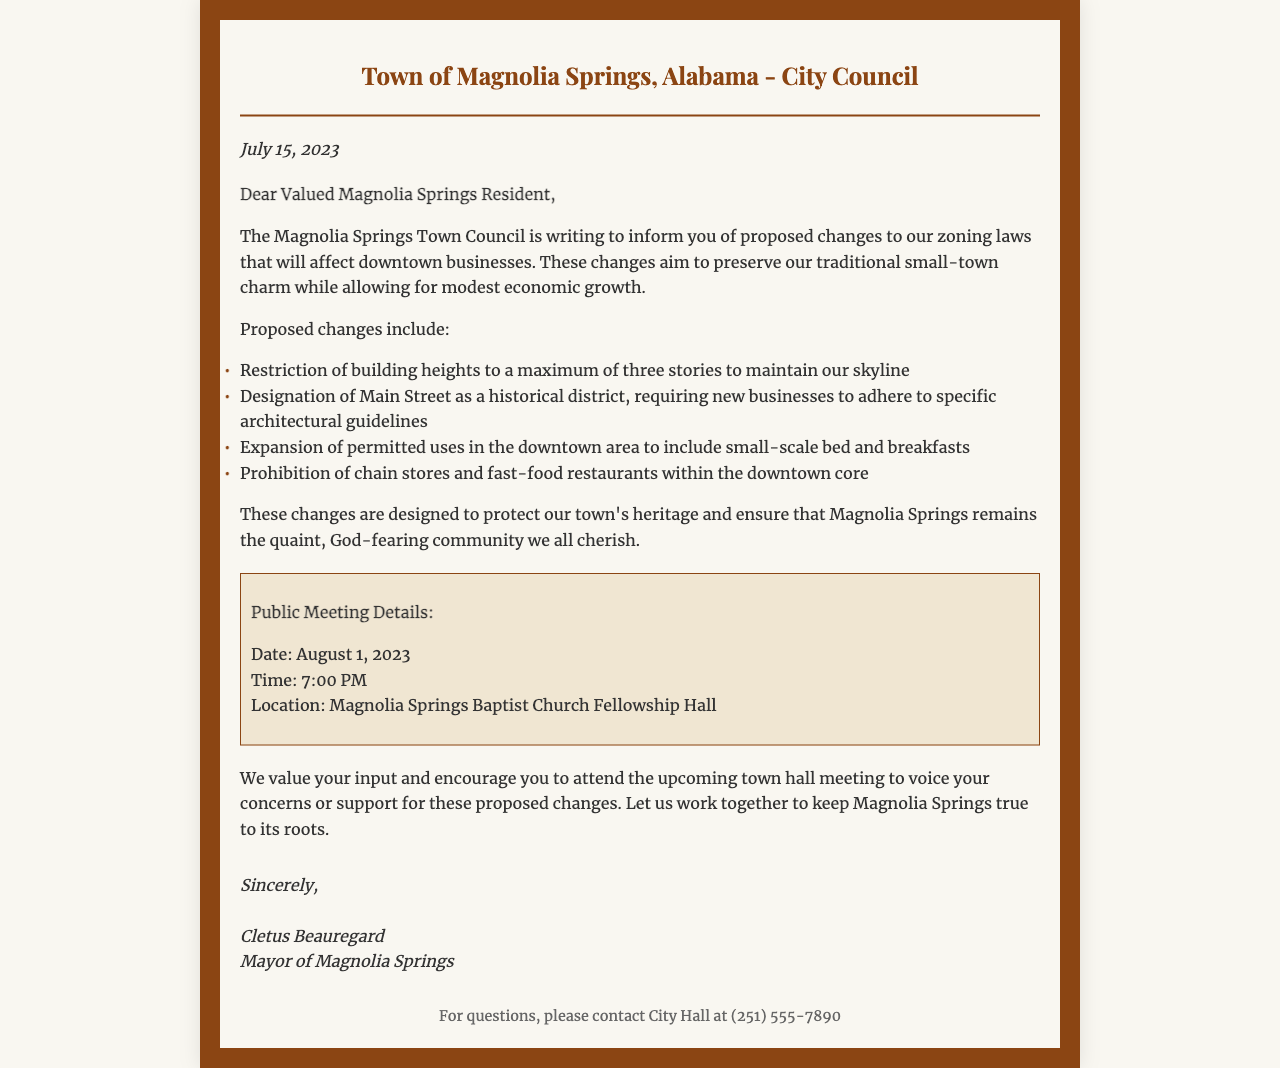What is the date of the letter? The letter is dated July 15, 2023, as indicated in the document.
Answer: July 15, 2023 Who is the mayor of Magnolia Springs? The mayor signing the letter is Cletus Beauregard, mentioned at the end of the document.
Answer: Cletus Beauregard What is the maximum building height proposed? The proposed maximum building height is three stories, as stated in the list of changes.
Answer: three stories What new business type is allowed in the downtown area? The document mentions the expansion of permitted uses to include small-scale bed and breakfasts.
Answer: small-scale bed and breakfasts When is the public meeting scheduled? The public meeting is scheduled for August 1, 2023, which is provided in the meeting details section.
Answer: August 1, 2023 What is prohibited within the downtown core? The proposed changes specifically prohibit chain stores and fast-food restaurants, as listed in the changes section.
Answer: chain stores and fast-food restaurants Where will the public meeting take place? The location of the public meeting is given as Magnolia Springs Baptist Church Fellowship Hall in the document.
Answer: Magnolia Springs Baptist Church Fellowship Hall What is the main goal of the proposed zoning law changes? The document states that the aim is to preserve traditional small-town charm while allowing for modest economic growth.
Answer: preserve traditional small-town charm 